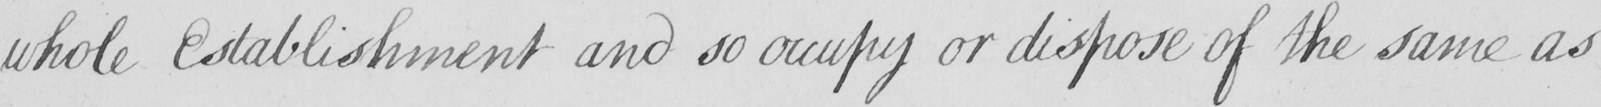What is written in this line of handwriting? whole Establishment and so occupy or dispose of the same as 